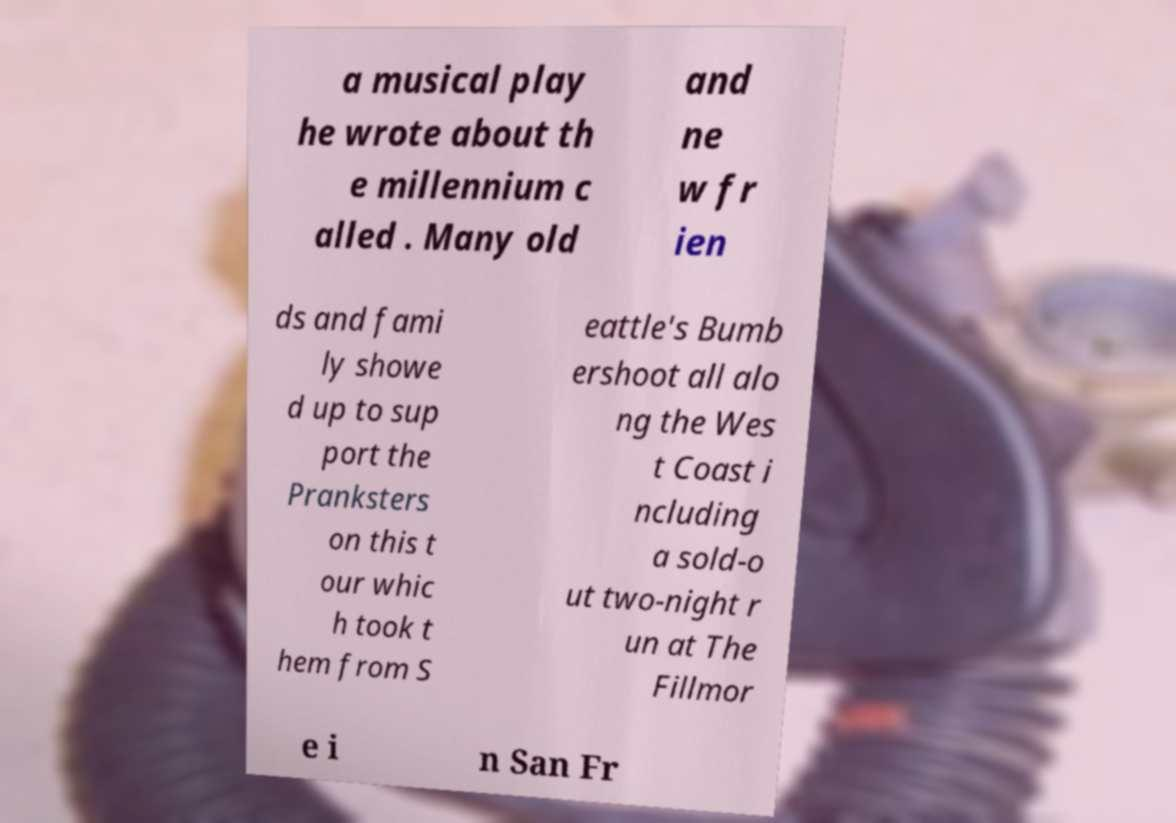There's text embedded in this image that I need extracted. Can you transcribe it verbatim? a musical play he wrote about th e millennium c alled . Many old and ne w fr ien ds and fami ly showe d up to sup port the Pranksters on this t our whic h took t hem from S eattle's Bumb ershoot all alo ng the Wes t Coast i ncluding a sold-o ut two-night r un at The Fillmor e i n San Fr 